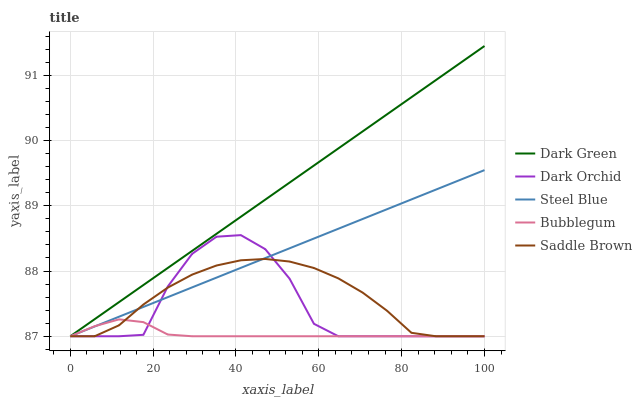Does Bubblegum have the minimum area under the curve?
Answer yes or no. Yes. Does Dark Green have the maximum area under the curve?
Answer yes or no. Yes. Does Steel Blue have the minimum area under the curve?
Answer yes or no. No. Does Steel Blue have the maximum area under the curve?
Answer yes or no. No. Is Steel Blue the smoothest?
Answer yes or no. Yes. Is Dark Orchid the roughest?
Answer yes or no. Yes. Is Bubblegum the smoothest?
Answer yes or no. No. Is Bubblegum the roughest?
Answer yes or no. No. Does Saddle Brown have the lowest value?
Answer yes or no. Yes. Does Dark Green have the highest value?
Answer yes or no. Yes. Does Steel Blue have the highest value?
Answer yes or no. No. Does Dark Green intersect Dark Orchid?
Answer yes or no. Yes. Is Dark Green less than Dark Orchid?
Answer yes or no. No. Is Dark Green greater than Dark Orchid?
Answer yes or no. No. 